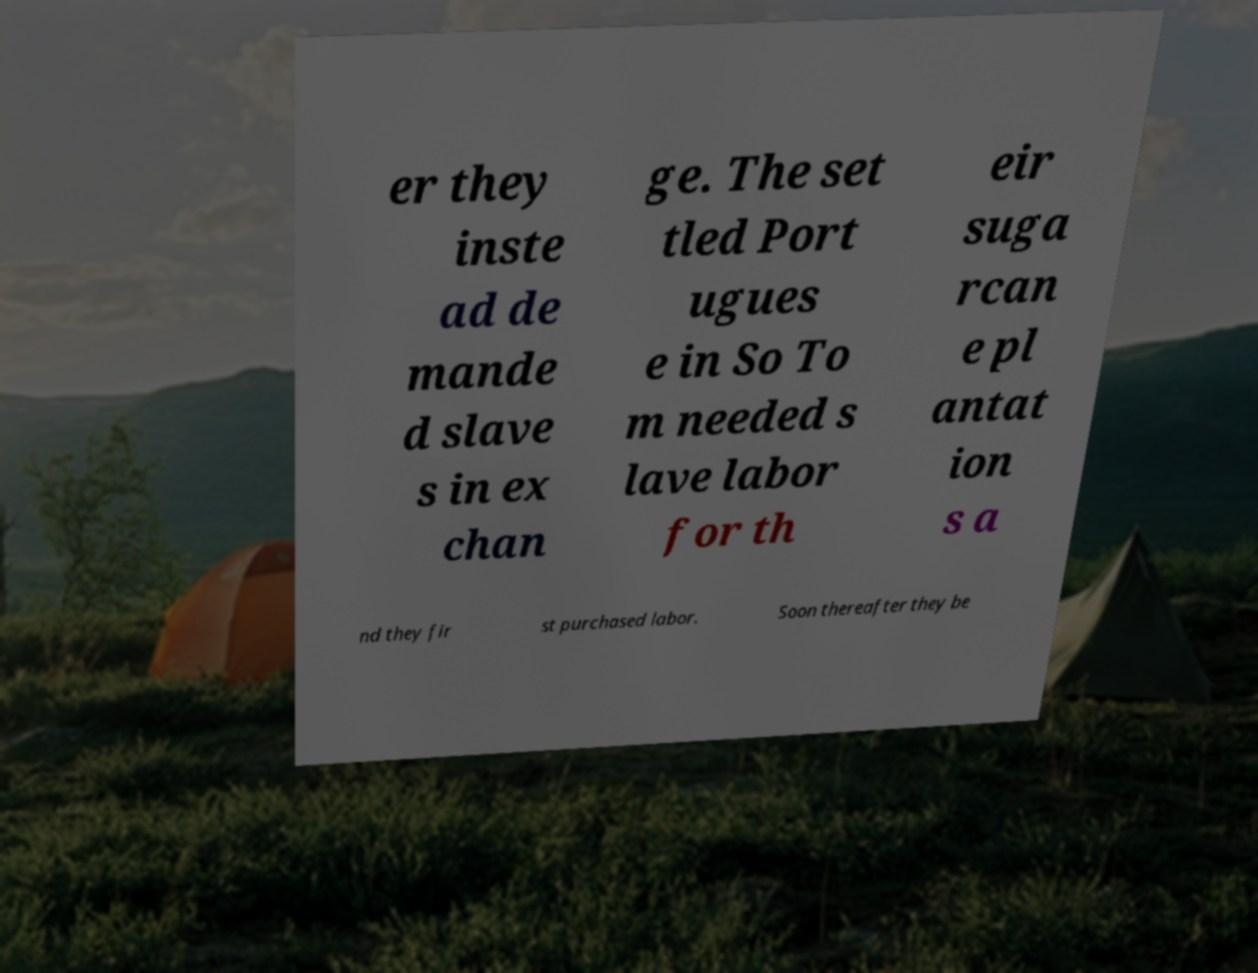Can you read and provide the text displayed in the image?This photo seems to have some interesting text. Can you extract and type it out for me? er they inste ad de mande d slave s in ex chan ge. The set tled Port ugues e in So To m needed s lave labor for th eir suga rcan e pl antat ion s a nd they fir st purchased labor. Soon thereafter they be 